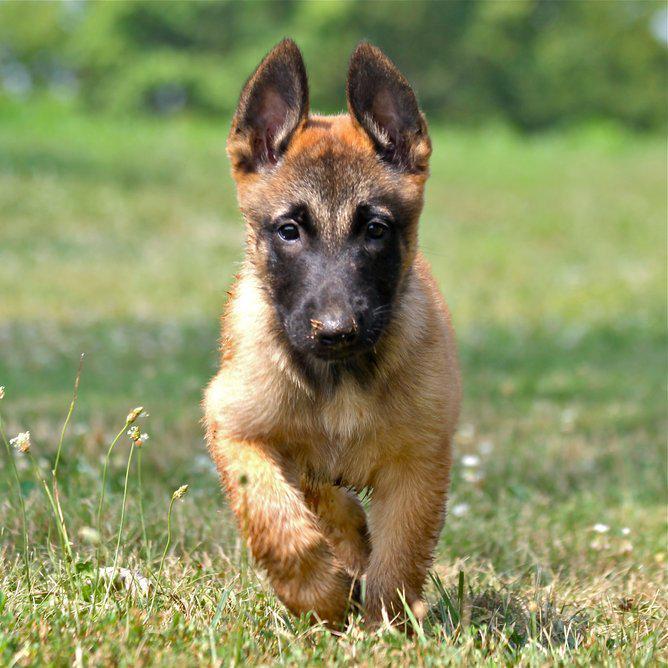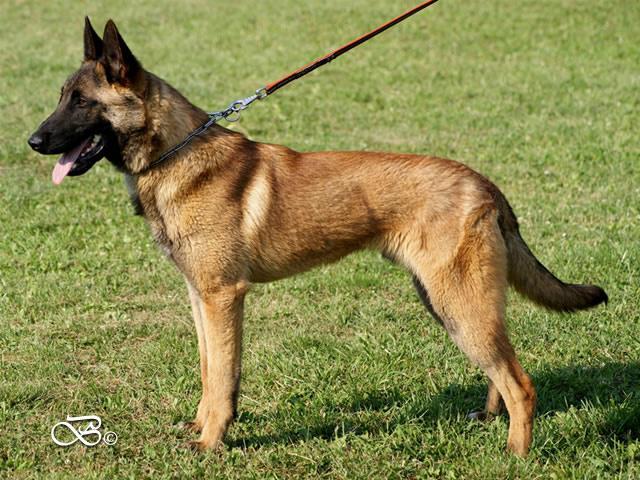The first image is the image on the left, the second image is the image on the right. Given the left and right images, does the statement "the right image has a dog standing on all 4's with a taught leash" hold true? Answer yes or no. Yes. 